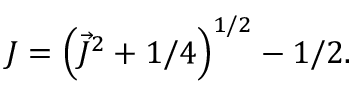Convert formula to latex. <formula><loc_0><loc_0><loc_500><loc_500>J = \left ( \vec { J } ^ { 2 } + 1 / 4 \right ) ^ { 1 / 2 } - 1 / 2 .</formula> 